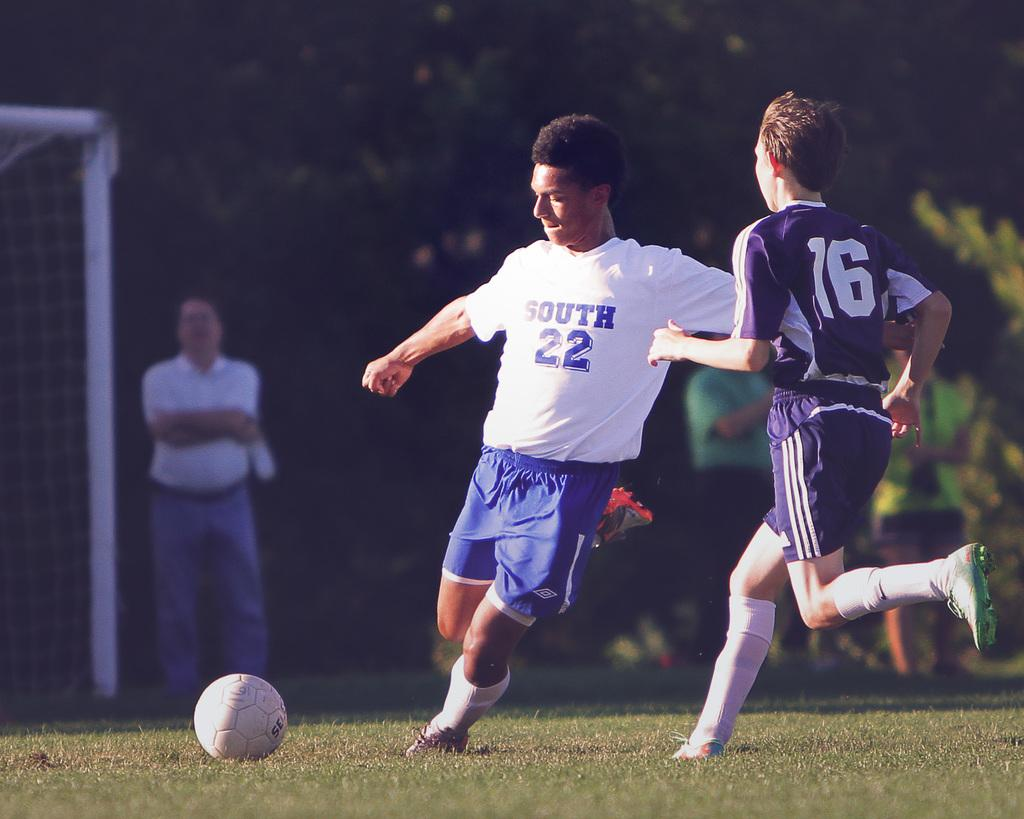Provide a one-sentence caption for the provided image. A soccer player has number 22 on his shirt. 